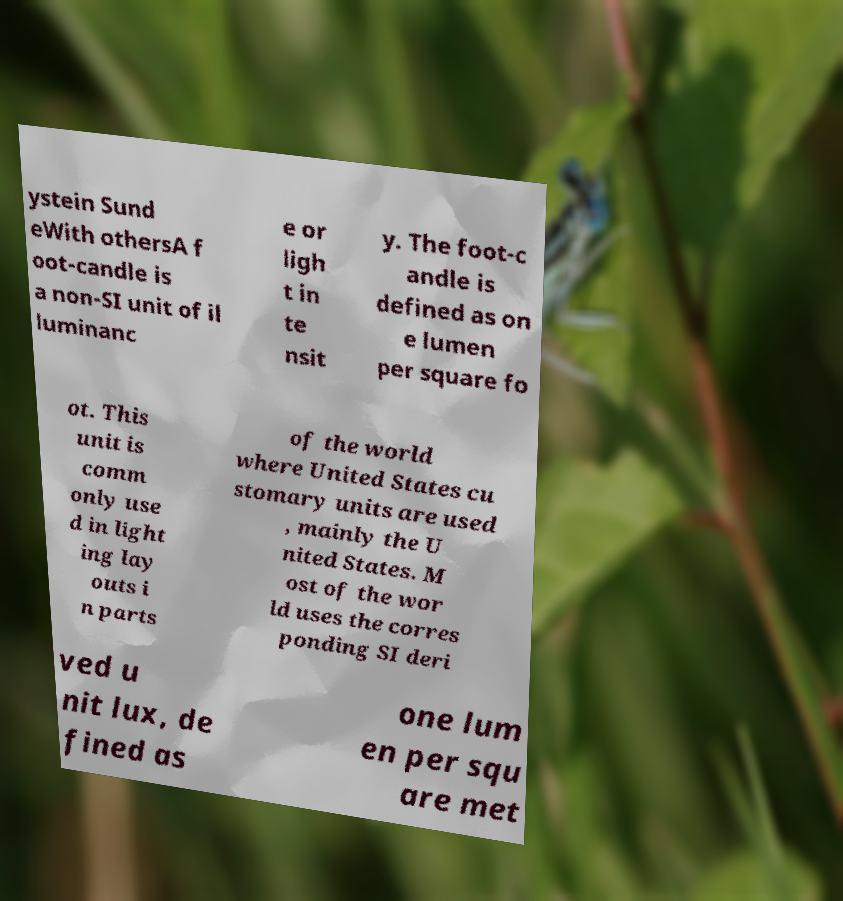Can you read and provide the text displayed in the image?This photo seems to have some interesting text. Can you extract and type it out for me? ystein Sund eWith othersA f oot-candle is a non-SI unit of il luminanc e or ligh t in te nsit y. The foot-c andle is defined as on e lumen per square fo ot. This unit is comm only use d in light ing lay outs i n parts of the world where United States cu stomary units are used , mainly the U nited States. M ost of the wor ld uses the corres ponding SI deri ved u nit lux, de fined as one lum en per squ are met 